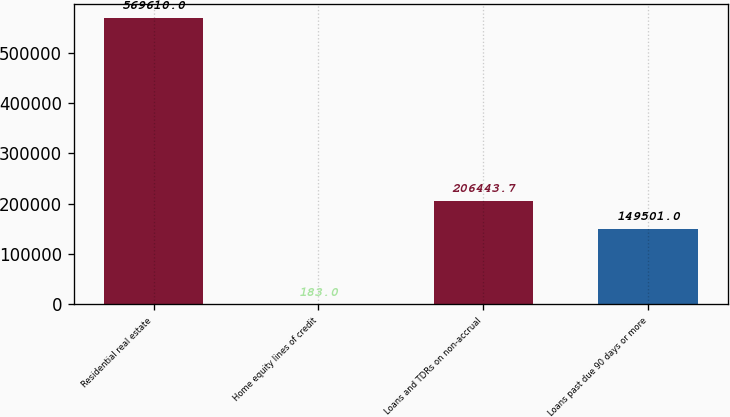<chart> <loc_0><loc_0><loc_500><loc_500><bar_chart><fcel>Residential real estate<fcel>Home equity lines of credit<fcel>Loans and TDRs on non-accrual<fcel>Loans past due 90 days or more<nl><fcel>569610<fcel>183<fcel>206444<fcel>149501<nl></chart> 